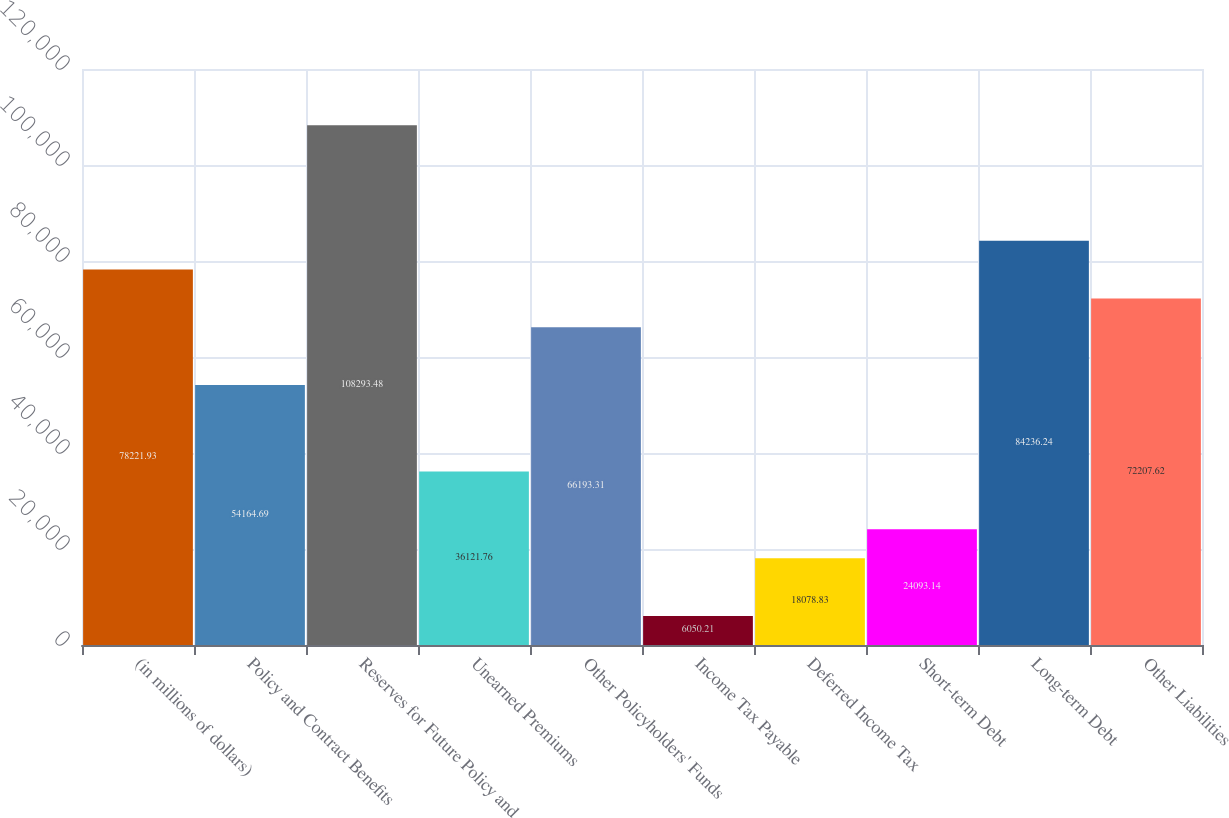<chart> <loc_0><loc_0><loc_500><loc_500><bar_chart><fcel>(in millions of dollars)<fcel>Policy and Contract Benefits<fcel>Reserves for Future Policy and<fcel>Unearned Premiums<fcel>Other Policyholders' Funds<fcel>Income Tax Payable<fcel>Deferred Income Tax<fcel>Short-term Debt<fcel>Long-term Debt<fcel>Other Liabilities<nl><fcel>78221.9<fcel>54164.7<fcel>108293<fcel>36121.8<fcel>66193.3<fcel>6050.21<fcel>18078.8<fcel>24093.1<fcel>84236.2<fcel>72207.6<nl></chart> 